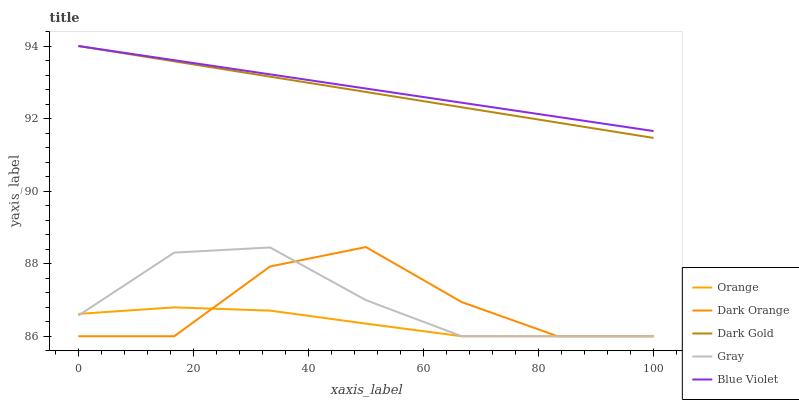Does Orange have the minimum area under the curve?
Answer yes or no. Yes. Does Blue Violet have the maximum area under the curve?
Answer yes or no. Yes. Does Dark Orange have the minimum area under the curve?
Answer yes or no. No. Does Dark Orange have the maximum area under the curve?
Answer yes or no. No. Is Blue Violet the smoothest?
Answer yes or no. Yes. Is Dark Orange the roughest?
Answer yes or no. Yes. Is Gray the smoothest?
Answer yes or no. No. Is Gray the roughest?
Answer yes or no. No. Does Orange have the lowest value?
Answer yes or no. Yes. Does Blue Violet have the lowest value?
Answer yes or no. No. Does Dark Gold have the highest value?
Answer yes or no. Yes. Does Dark Orange have the highest value?
Answer yes or no. No. Is Gray less than Dark Gold?
Answer yes or no. Yes. Is Dark Gold greater than Gray?
Answer yes or no. Yes. Does Dark Orange intersect Gray?
Answer yes or no. Yes. Is Dark Orange less than Gray?
Answer yes or no. No. Is Dark Orange greater than Gray?
Answer yes or no. No. Does Gray intersect Dark Gold?
Answer yes or no. No. 